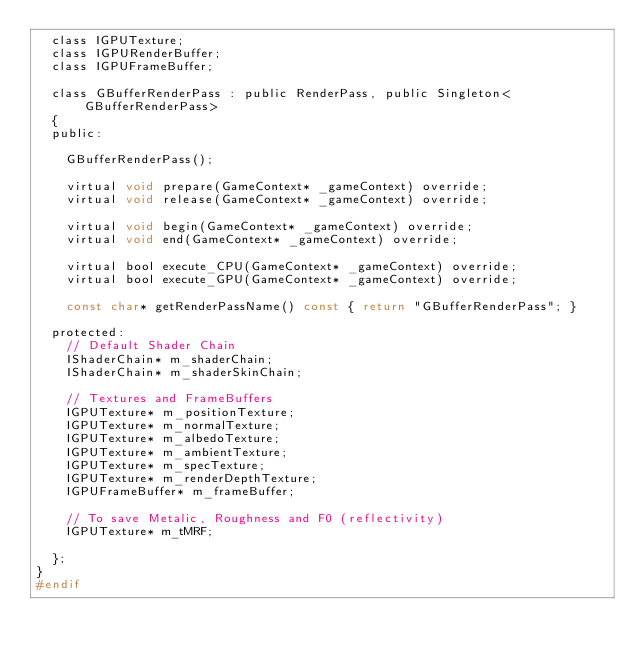Convert code to text. <code><loc_0><loc_0><loc_500><loc_500><_C_>	class IGPUTexture;
	class IGPURenderBuffer;
	class IGPUFrameBuffer;

	class GBufferRenderPass : public RenderPass, public Singleton<GBufferRenderPass>
	{
	public:

		GBufferRenderPass();
		
		virtual void prepare(GameContext* _gameContext) override;
		virtual void release(GameContext* _gameContext) override;

		virtual void begin(GameContext* _gameContext) override;
		virtual void end(GameContext* _gameContext) override;

		virtual bool execute_CPU(GameContext* _gameContext) override;
		virtual bool execute_GPU(GameContext* _gameContext) override;

		const char* getRenderPassName() const { return "GBufferRenderPass"; }

	protected:
		// Default Shader Chain
		IShaderChain* m_shaderChain;
		IShaderChain* m_shaderSkinChain;

		// Textures and FrameBuffers
		IGPUTexture* m_positionTexture;
		IGPUTexture* m_normalTexture;
		IGPUTexture* m_albedoTexture;
		IGPUTexture* m_ambientTexture;
		IGPUTexture* m_specTexture;
		IGPUTexture* m_renderDepthTexture;
		IGPUFrameBuffer* m_frameBuffer;

		// To save Metalic, Roughness and F0 (reflectivity)
		IGPUTexture* m_tMRF;

	};
}
#endif
</code> 